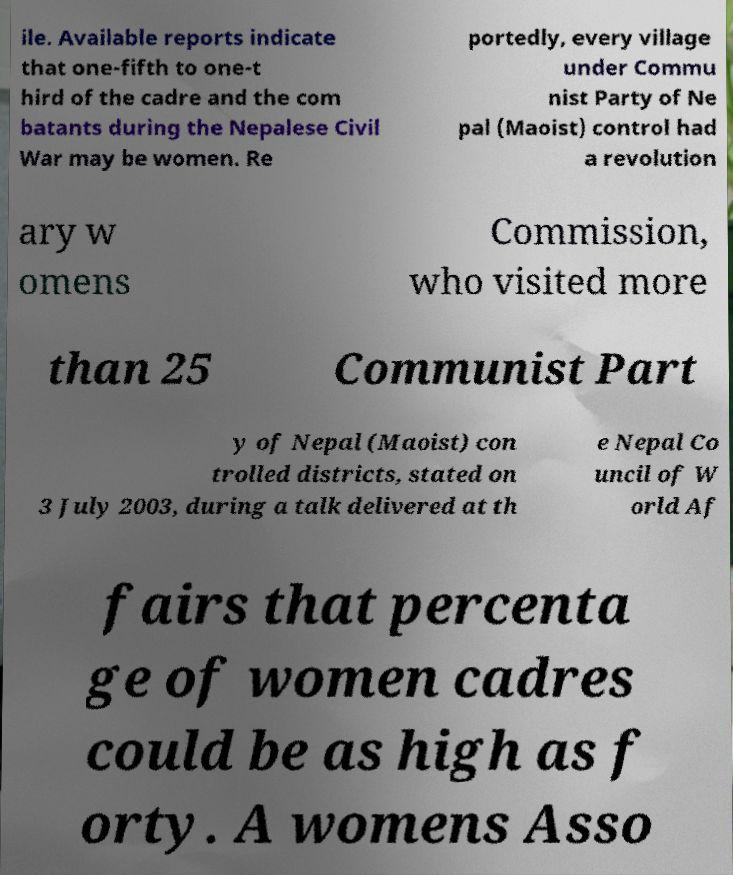Could you extract and type out the text from this image? ile. Available reports indicate that one-fifth to one-t hird of the cadre and the com batants during the Nepalese Civil War may be women. Re portedly, every village under Commu nist Party of Ne pal (Maoist) control had a revolution ary w omens Commission, who visited more than 25 Communist Part y of Nepal (Maoist) con trolled districts, stated on 3 July 2003, during a talk delivered at th e Nepal Co uncil of W orld Af fairs that percenta ge of women cadres could be as high as f orty. A womens Asso 